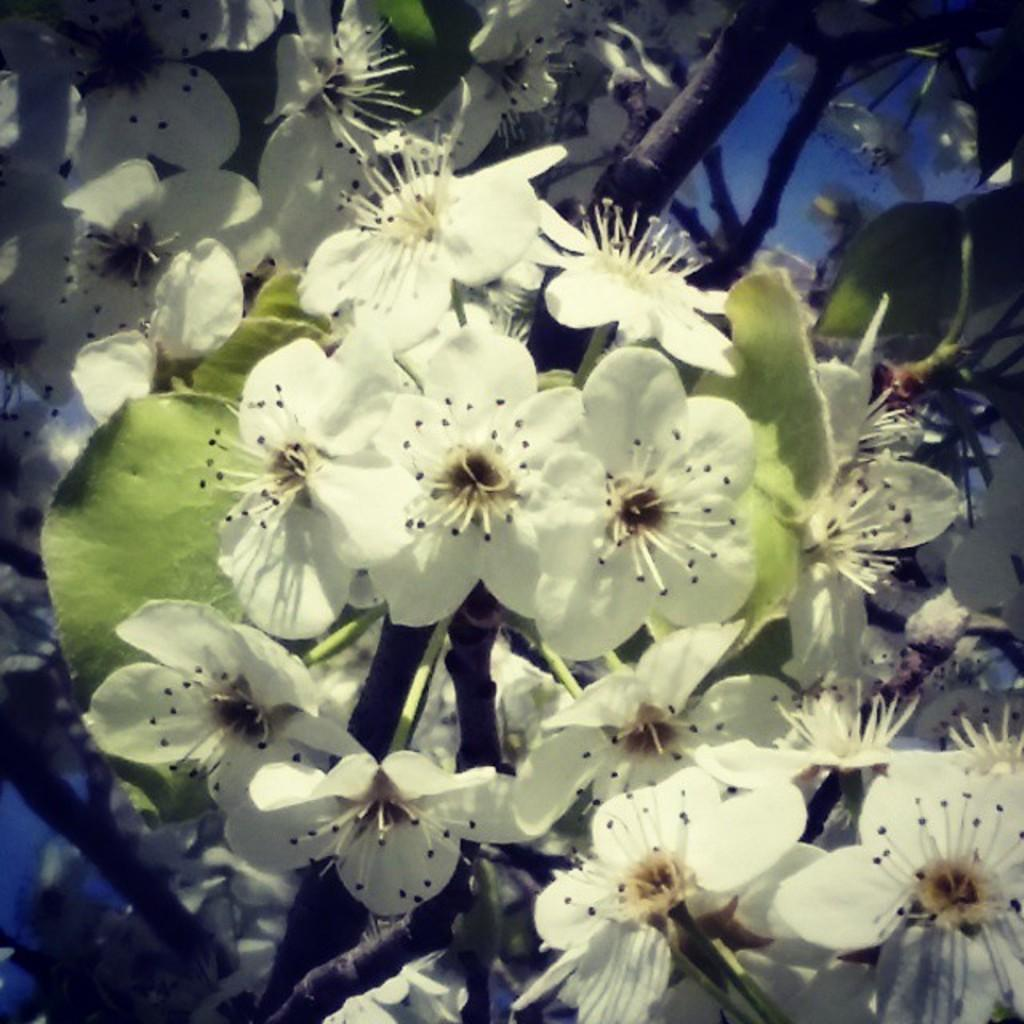What type of plant parts can be seen in the image? There are flowers, leaves, and stems in the image. Can you describe the flowers in the image? The flowers in the image have petals and various colors. What is the purpose of the stems in the image? The stems in the image provide support for the flowers and leaves. How does the flower use its nose to smell the air in the image? There are no flowers with noses in the image, as flowers do not have noses. 